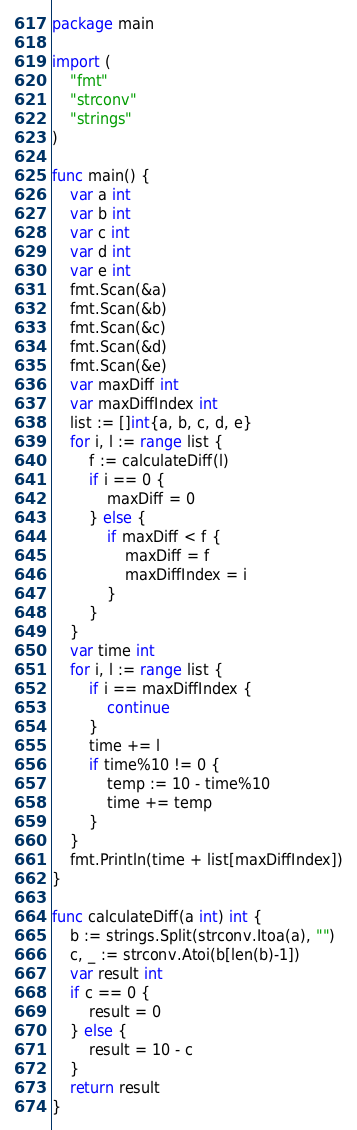Convert code to text. <code><loc_0><loc_0><loc_500><loc_500><_Go_>package main

import (
	"fmt"
	"strconv"
	"strings"
)

func main() {
	var a int
	var b int
	var c int
	var d int
	var e int
	fmt.Scan(&a)
	fmt.Scan(&b)
	fmt.Scan(&c)
	fmt.Scan(&d)
	fmt.Scan(&e)
	var maxDiff int
	var maxDiffIndex int
	list := []int{a, b, c, d, e}
	for i, l := range list {
		f := calculateDiff(l)
		if i == 0 {
			maxDiff = 0
		} else {
			if maxDiff < f {
				maxDiff = f
				maxDiffIndex = i
			}
		}
	}
	var time int
	for i, l := range list {
		if i == maxDiffIndex {
			continue
		}
		time += l
		if time%10 != 0 {
			temp := 10 - time%10
			time += temp
		}
	}
	fmt.Println(time + list[maxDiffIndex])
}

func calculateDiff(a int) int {
	b := strings.Split(strconv.Itoa(a), "")
	c, _ := strconv.Atoi(b[len(b)-1])
	var result int
	if c == 0 {
		result = 0
	} else {
		result = 10 - c
	}
	return result
}
</code> 